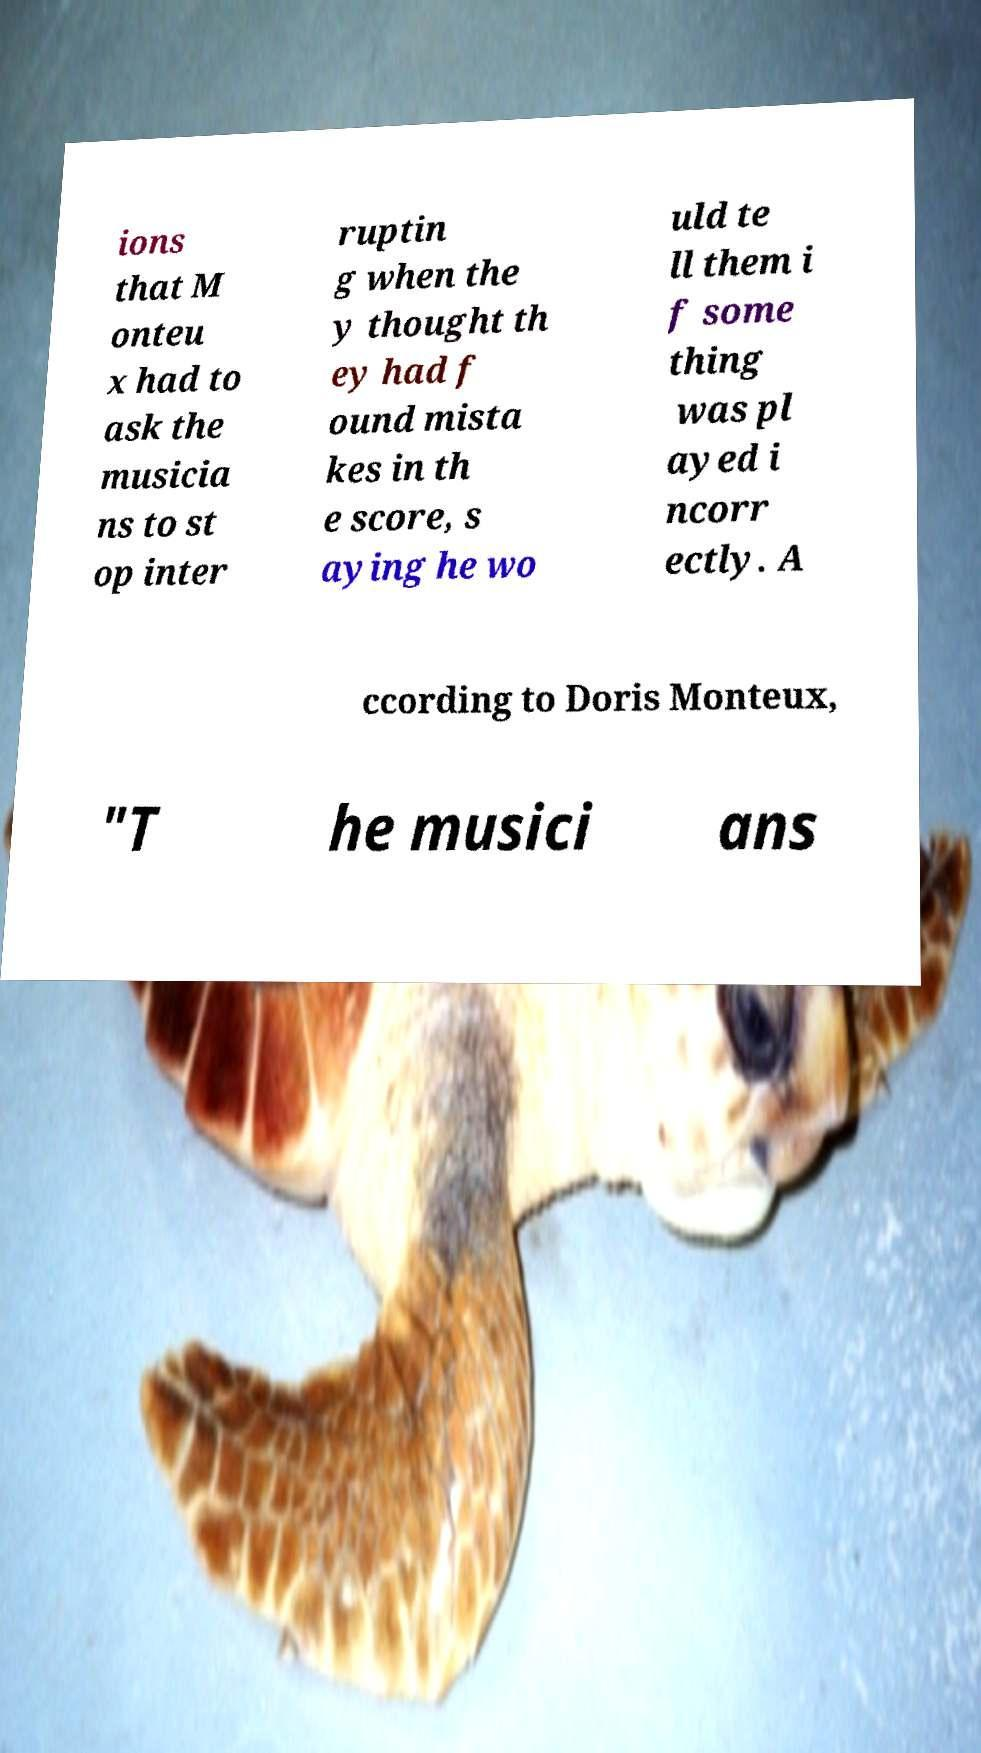I need the written content from this picture converted into text. Can you do that? ions that M onteu x had to ask the musicia ns to st op inter ruptin g when the y thought th ey had f ound mista kes in th e score, s aying he wo uld te ll them i f some thing was pl ayed i ncorr ectly. A ccording to Doris Monteux, "T he musici ans 